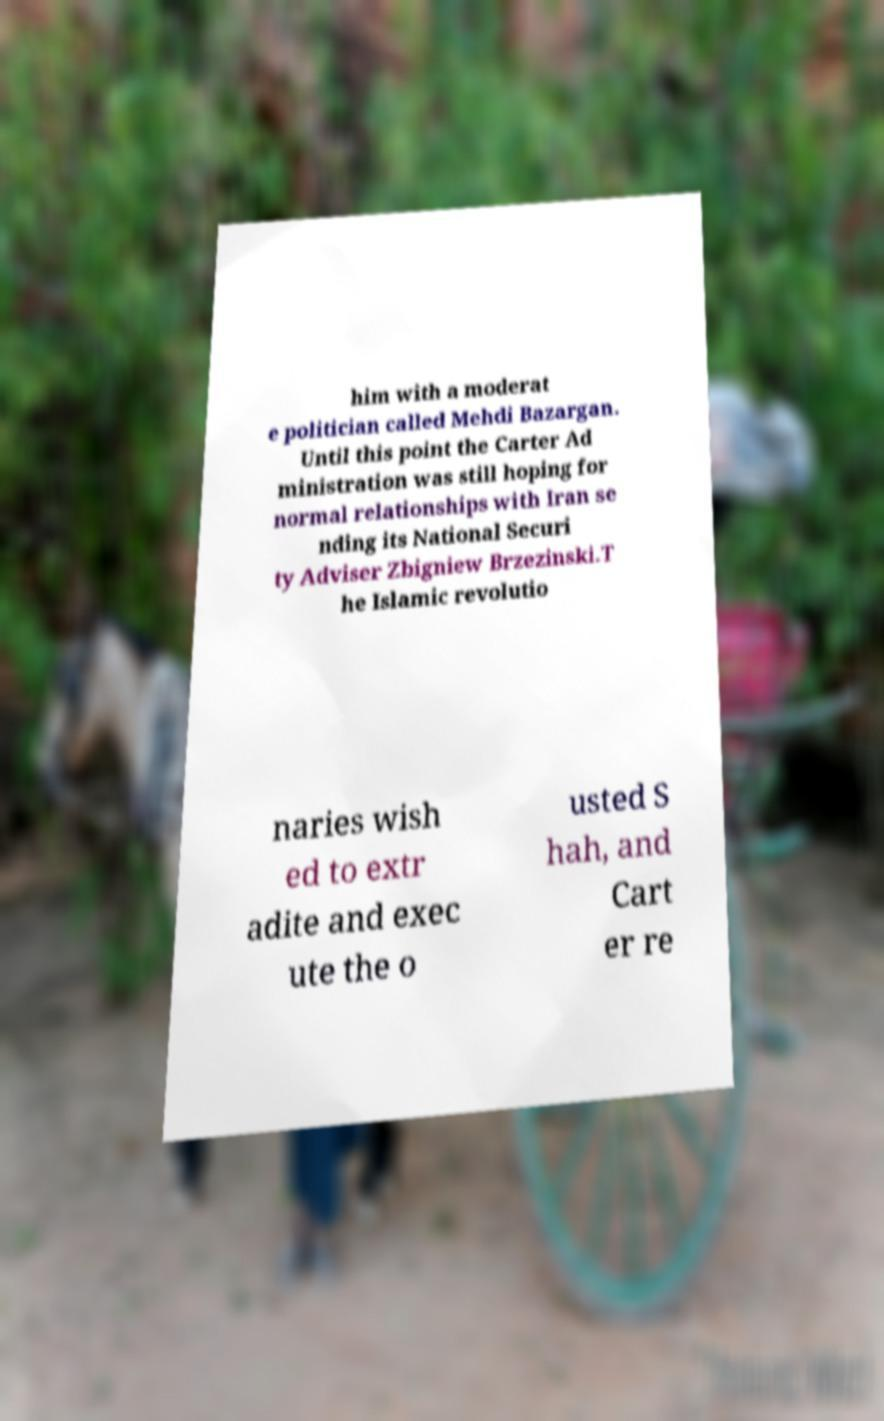Can you read and provide the text displayed in the image?This photo seems to have some interesting text. Can you extract and type it out for me? him with a moderat e politician called Mehdi Bazargan. Until this point the Carter Ad ministration was still hoping for normal relationships with Iran se nding its National Securi ty Adviser Zbigniew Brzezinski.T he Islamic revolutio naries wish ed to extr adite and exec ute the o usted S hah, and Cart er re 